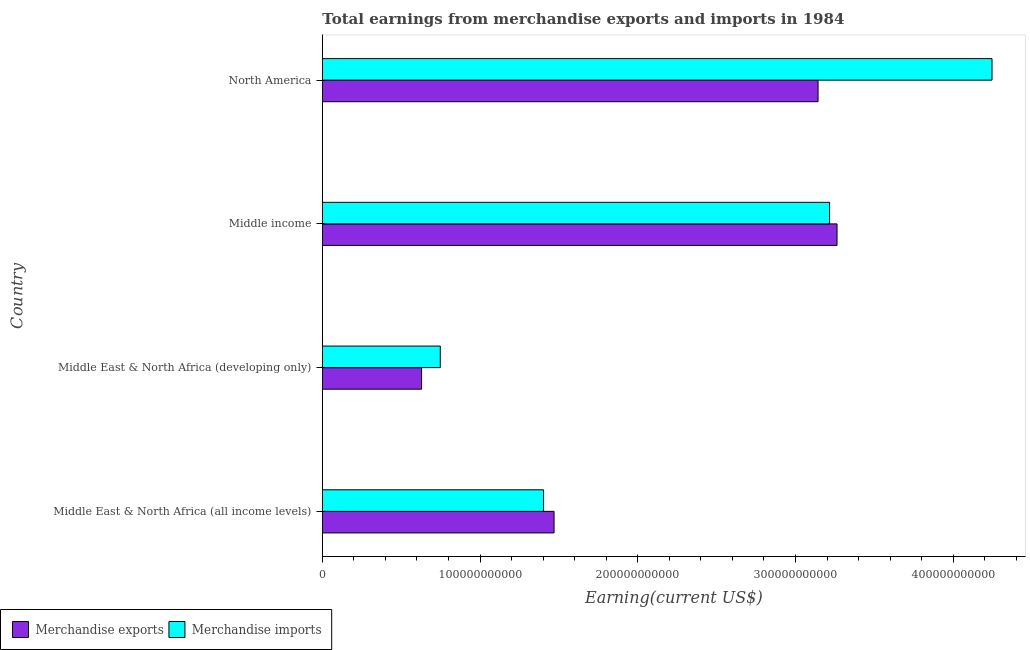How many different coloured bars are there?
Your answer should be compact. 2. Are the number of bars per tick equal to the number of legend labels?
Make the answer very short. Yes. How many bars are there on the 2nd tick from the bottom?
Offer a terse response. 2. What is the label of the 1st group of bars from the top?
Provide a short and direct response. North America. What is the earnings from merchandise imports in Middle East & North Africa (developing only)?
Your answer should be compact. 7.48e+1. Across all countries, what is the maximum earnings from merchandise exports?
Offer a terse response. 3.26e+11. Across all countries, what is the minimum earnings from merchandise imports?
Offer a terse response. 7.48e+1. In which country was the earnings from merchandise imports maximum?
Your answer should be compact. North America. In which country was the earnings from merchandise imports minimum?
Give a very brief answer. Middle East & North Africa (developing only). What is the total earnings from merchandise exports in the graph?
Your answer should be very brief. 8.50e+11. What is the difference between the earnings from merchandise imports in Middle East & North Africa (all income levels) and that in Middle income?
Ensure brevity in your answer.  -1.81e+11. What is the difference between the earnings from merchandise imports in Middle income and the earnings from merchandise exports in North America?
Keep it short and to the point. 7.31e+09. What is the average earnings from merchandise exports per country?
Your answer should be very brief. 2.13e+11. What is the difference between the earnings from merchandise exports and earnings from merchandise imports in Middle East & North Africa (all income levels)?
Ensure brevity in your answer.  6.64e+09. What is the ratio of the earnings from merchandise imports in Middle East & North Africa (all income levels) to that in Middle East & North Africa (developing only)?
Provide a short and direct response. 1.88. Is the earnings from merchandise imports in Middle East & North Africa (all income levels) less than that in Middle East & North Africa (developing only)?
Offer a very short reply. No. Is the difference between the earnings from merchandise exports in Middle income and North America greater than the difference between the earnings from merchandise imports in Middle income and North America?
Your answer should be compact. Yes. What is the difference between the highest and the second highest earnings from merchandise imports?
Keep it short and to the point. 1.03e+11. What is the difference between the highest and the lowest earnings from merchandise exports?
Keep it short and to the point. 2.63e+11. What is the difference between two consecutive major ticks on the X-axis?
Keep it short and to the point. 1.00e+11. Does the graph contain any zero values?
Make the answer very short. No. Does the graph contain grids?
Ensure brevity in your answer.  No. How many legend labels are there?
Offer a terse response. 2. What is the title of the graph?
Offer a very short reply. Total earnings from merchandise exports and imports in 1984. What is the label or title of the X-axis?
Your answer should be very brief. Earning(current US$). What is the label or title of the Y-axis?
Give a very brief answer. Country. What is the Earning(current US$) in Merchandise exports in Middle East & North Africa (all income levels)?
Give a very brief answer. 1.47e+11. What is the Earning(current US$) in Merchandise imports in Middle East & North Africa (all income levels)?
Your answer should be compact. 1.40e+11. What is the Earning(current US$) in Merchandise exports in Middle East & North Africa (developing only)?
Make the answer very short. 6.29e+1. What is the Earning(current US$) in Merchandise imports in Middle East & North Africa (developing only)?
Provide a succinct answer. 7.48e+1. What is the Earning(current US$) in Merchandise exports in Middle income?
Your answer should be compact. 3.26e+11. What is the Earning(current US$) of Merchandise imports in Middle income?
Keep it short and to the point. 3.22e+11. What is the Earning(current US$) in Merchandise exports in North America?
Keep it short and to the point. 3.14e+11. What is the Earning(current US$) in Merchandise imports in North America?
Ensure brevity in your answer.  4.25e+11. Across all countries, what is the maximum Earning(current US$) of Merchandise exports?
Make the answer very short. 3.26e+11. Across all countries, what is the maximum Earning(current US$) of Merchandise imports?
Offer a very short reply. 4.25e+11. Across all countries, what is the minimum Earning(current US$) in Merchandise exports?
Offer a terse response. 6.29e+1. Across all countries, what is the minimum Earning(current US$) in Merchandise imports?
Your answer should be very brief. 7.48e+1. What is the total Earning(current US$) of Merchandise exports in the graph?
Offer a terse response. 8.50e+11. What is the total Earning(current US$) in Merchandise imports in the graph?
Offer a terse response. 9.61e+11. What is the difference between the Earning(current US$) of Merchandise exports in Middle East & North Africa (all income levels) and that in Middle East & North Africa (developing only)?
Keep it short and to the point. 8.40e+1. What is the difference between the Earning(current US$) in Merchandise imports in Middle East & North Africa (all income levels) and that in Middle East & North Africa (developing only)?
Give a very brief answer. 6.55e+1. What is the difference between the Earning(current US$) of Merchandise exports in Middle East & North Africa (all income levels) and that in Middle income?
Give a very brief answer. -1.79e+11. What is the difference between the Earning(current US$) of Merchandise imports in Middle East & North Africa (all income levels) and that in Middle income?
Give a very brief answer. -1.81e+11. What is the difference between the Earning(current US$) of Merchandise exports in Middle East & North Africa (all income levels) and that in North America?
Your response must be concise. -1.67e+11. What is the difference between the Earning(current US$) in Merchandise imports in Middle East & North Africa (all income levels) and that in North America?
Ensure brevity in your answer.  -2.84e+11. What is the difference between the Earning(current US$) in Merchandise exports in Middle East & North Africa (developing only) and that in Middle income?
Make the answer very short. -2.63e+11. What is the difference between the Earning(current US$) of Merchandise imports in Middle East & North Africa (developing only) and that in Middle income?
Give a very brief answer. -2.47e+11. What is the difference between the Earning(current US$) in Merchandise exports in Middle East & North Africa (developing only) and that in North America?
Provide a short and direct response. -2.51e+11. What is the difference between the Earning(current US$) in Merchandise imports in Middle East & North Africa (developing only) and that in North America?
Your answer should be compact. -3.50e+11. What is the difference between the Earning(current US$) of Merchandise exports in Middle income and that in North America?
Your answer should be compact. 1.20e+1. What is the difference between the Earning(current US$) in Merchandise imports in Middle income and that in North America?
Your response must be concise. -1.03e+11. What is the difference between the Earning(current US$) of Merchandise exports in Middle East & North Africa (all income levels) and the Earning(current US$) of Merchandise imports in Middle East & North Africa (developing only)?
Keep it short and to the point. 7.21e+1. What is the difference between the Earning(current US$) of Merchandise exports in Middle East & North Africa (all income levels) and the Earning(current US$) of Merchandise imports in Middle income?
Your response must be concise. -1.75e+11. What is the difference between the Earning(current US$) in Merchandise exports in Middle East & North Africa (all income levels) and the Earning(current US$) in Merchandise imports in North America?
Provide a short and direct response. -2.78e+11. What is the difference between the Earning(current US$) of Merchandise exports in Middle East & North Africa (developing only) and the Earning(current US$) of Merchandise imports in Middle income?
Provide a short and direct response. -2.59e+11. What is the difference between the Earning(current US$) in Merchandise exports in Middle East & North Africa (developing only) and the Earning(current US$) in Merchandise imports in North America?
Offer a terse response. -3.62e+11. What is the difference between the Earning(current US$) in Merchandise exports in Middle income and the Earning(current US$) in Merchandise imports in North America?
Offer a terse response. -9.83e+1. What is the average Earning(current US$) in Merchandise exports per country?
Your response must be concise. 2.13e+11. What is the average Earning(current US$) in Merchandise imports per country?
Ensure brevity in your answer.  2.40e+11. What is the difference between the Earning(current US$) of Merchandise exports and Earning(current US$) of Merchandise imports in Middle East & North Africa (all income levels)?
Ensure brevity in your answer.  6.64e+09. What is the difference between the Earning(current US$) in Merchandise exports and Earning(current US$) in Merchandise imports in Middle East & North Africa (developing only)?
Offer a very short reply. -1.19e+1. What is the difference between the Earning(current US$) of Merchandise exports and Earning(current US$) of Merchandise imports in Middle income?
Make the answer very short. 4.71e+09. What is the difference between the Earning(current US$) of Merchandise exports and Earning(current US$) of Merchandise imports in North America?
Keep it short and to the point. -1.10e+11. What is the ratio of the Earning(current US$) of Merchandise exports in Middle East & North Africa (all income levels) to that in Middle East & North Africa (developing only)?
Your answer should be compact. 2.33. What is the ratio of the Earning(current US$) of Merchandise imports in Middle East & North Africa (all income levels) to that in Middle East & North Africa (developing only)?
Make the answer very short. 1.88. What is the ratio of the Earning(current US$) in Merchandise exports in Middle East & North Africa (all income levels) to that in Middle income?
Your answer should be compact. 0.45. What is the ratio of the Earning(current US$) of Merchandise imports in Middle East & North Africa (all income levels) to that in Middle income?
Your response must be concise. 0.44. What is the ratio of the Earning(current US$) of Merchandise exports in Middle East & North Africa (all income levels) to that in North America?
Your response must be concise. 0.47. What is the ratio of the Earning(current US$) of Merchandise imports in Middle East & North Africa (all income levels) to that in North America?
Offer a very short reply. 0.33. What is the ratio of the Earning(current US$) of Merchandise exports in Middle East & North Africa (developing only) to that in Middle income?
Provide a succinct answer. 0.19. What is the ratio of the Earning(current US$) in Merchandise imports in Middle East & North Africa (developing only) to that in Middle income?
Offer a very short reply. 0.23. What is the ratio of the Earning(current US$) of Merchandise exports in Middle East & North Africa (developing only) to that in North America?
Offer a terse response. 0.2. What is the ratio of the Earning(current US$) of Merchandise imports in Middle East & North Africa (developing only) to that in North America?
Ensure brevity in your answer.  0.18. What is the ratio of the Earning(current US$) of Merchandise exports in Middle income to that in North America?
Your response must be concise. 1.04. What is the ratio of the Earning(current US$) in Merchandise imports in Middle income to that in North America?
Your answer should be very brief. 0.76. What is the difference between the highest and the second highest Earning(current US$) of Merchandise exports?
Provide a short and direct response. 1.20e+1. What is the difference between the highest and the second highest Earning(current US$) in Merchandise imports?
Give a very brief answer. 1.03e+11. What is the difference between the highest and the lowest Earning(current US$) in Merchandise exports?
Your answer should be very brief. 2.63e+11. What is the difference between the highest and the lowest Earning(current US$) of Merchandise imports?
Your response must be concise. 3.50e+11. 